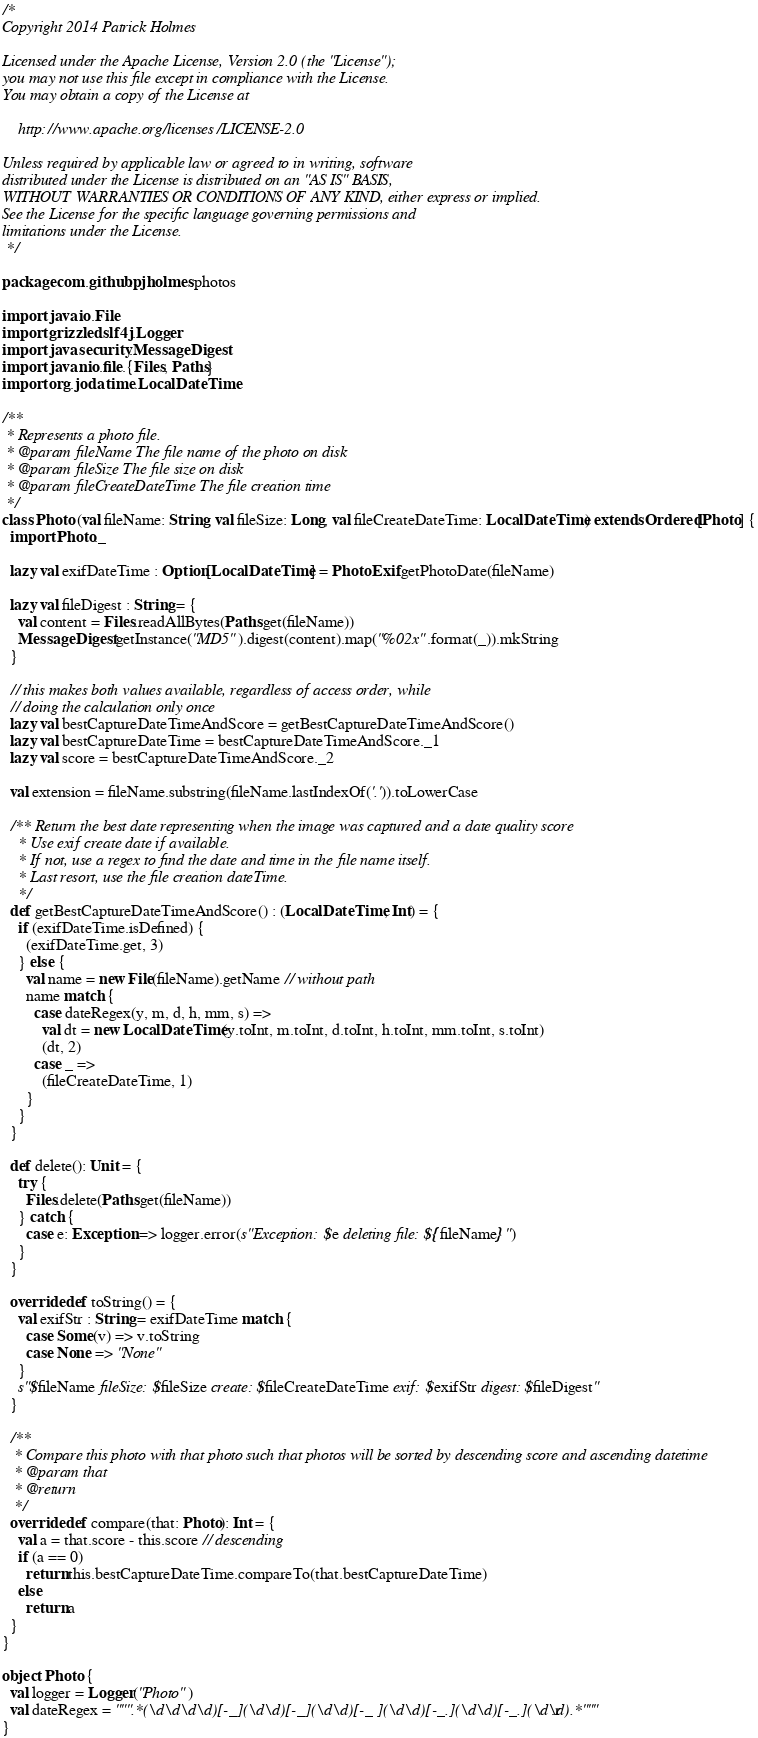<code> <loc_0><loc_0><loc_500><loc_500><_Scala_>/*
Copyright 2014 Patrick Holmes

Licensed under the Apache License, Version 2.0 (the "License");
you may not use this file except in compliance with the License.
You may obtain a copy of the License at

    http://www.apache.org/licenses/LICENSE-2.0

Unless required by applicable law or agreed to in writing, software
distributed under the License is distributed on an "AS IS" BASIS,
WITHOUT WARRANTIES OR CONDITIONS OF ANY KIND, either express or implied.
See the License for the specific language governing permissions and
limitations under the License.
 */

package com.github.pjholmes.photos

import java.io.File
import grizzled.slf4j.Logger
import java.security.MessageDigest
import java.nio.file.{Files, Paths}
import org.joda.time.LocalDateTime

/**
 * Represents a photo file.
 * @param fileName The file name of the photo on disk
 * @param fileSize The file size on disk
 * @param fileCreateDateTime The file creation time
 */
class Photo (val fileName: String, val fileSize: Long, val fileCreateDateTime: LocalDateTime) extends Ordered[Photo] {
  import Photo._

  lazy val exifDateTime : Option[LocalDateTime] = PhotoExif.getPhotoDate(fileName)

  lazy val fileDigest : String = {
    val content = Files.readAllBytes(Paths.get(fileName))
    MessageDigest.getInstance("MD5").digest(content).map("%02x".format(_)).mkString
  }

  // this makes both values available, regardless of access order, while
  // doing the calculation only once
  lazy val bestCaptureDateTimeAndScore = getBestCaptureDateTimeAndScore()
  lazy val bestCaptureDateTime = bestCaptureDateTimeAndScore._1
  lazy val score = bestCaptureDateTimeAndScore._2

  val extension = fileName.substring(fileName.lastIndexOf('.')).toLowerCase

  /** Return the best date representing when the image was captured and a date quality score
    * Use exif create date if available.
    * If not, use a regex to find the date and time in the file name itself.
    * Last resort, use the file creation dateTime.
    */
  def getBestCaptureDateTimeAndScore() : (LocalDateTime, Int) = {
    if (exifDateTime.isDefined) {
      (exifDateTime.get, 3)
    } else {
      val name = new File(fileName).getName // without path
      name match {
        case dateRegex(y, m, d, h, mm, s) =>
          val dt = new LocalDateTime(y.toInt, m.toInt, d.toInt, h.toInt, mm.toInt, s.toInt)
          (dt, 2)
        case _ =>
          (fileCreateDateTime, 1)
      }
    }
  }

  def delete(): Unit = {
    try {
      Files.delete(Paths.get(fileName))
    } catch {
      case e: Exception => logger.error(s"Exception: $e deleting file: ${fileName}")
    }
  }

  override def toString() = {
    val exifStr : String = exifDateTime match {
      case Some(v) => v.toString
      case None => "None"
    }
    s"$fileName fileSize: $fileSize create: $fileCreateDateTime exif: $exifStr digest: $fileDigest"
  }

  /**
   * Compare this photo with that photo such that photos will be sorted by descending score and ascending datetime
   * @param that
   * @return
   */
  override def compare(that: Photo): Int = {
    val a = that.score - this.score // descending
    if (a == 0)
      return this.bestCaptureDateTime.compareTo(that.bestCaptureDateTime)
    else
      return a
  }
}

object Photo {
  val logger = Logger("Photo")
  val dateRegex = """.*(\d\d\d\d)[-_](\d\d)[-_](\d\d)[-_ ](\d\d)[-_.](\d\d)[-_.](\d\d).*""".r
}

</code> 